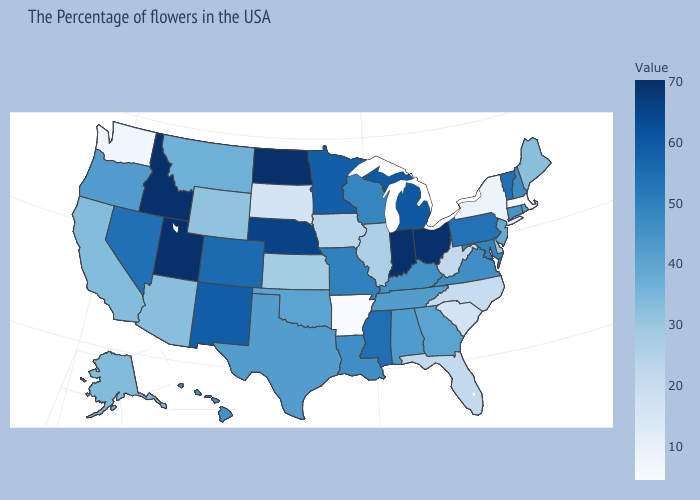Does Arkansas have the lowest value in the USA?
Quick response, please. Yes. Does Delaware have the highest value in the USA?
Write a very short answer. No. Among the states that border New York , does Massachusetts have the lowest value?
Be succinct. Yes. 